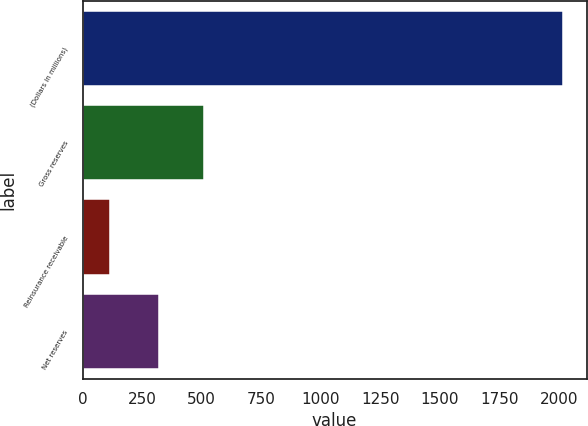Convert chart to OTSL. <chart><loc_0><loc_0><loc_500><loc_500><bar_chart><fcel>(Dollars in millions)<fcel>Gross reserves<fcel>Reinsurance receivable<fcel>Net reserves<nl><fcel>2015<fcel>509.75<fcel>113.5<fcel>319.6<nl></chart> 